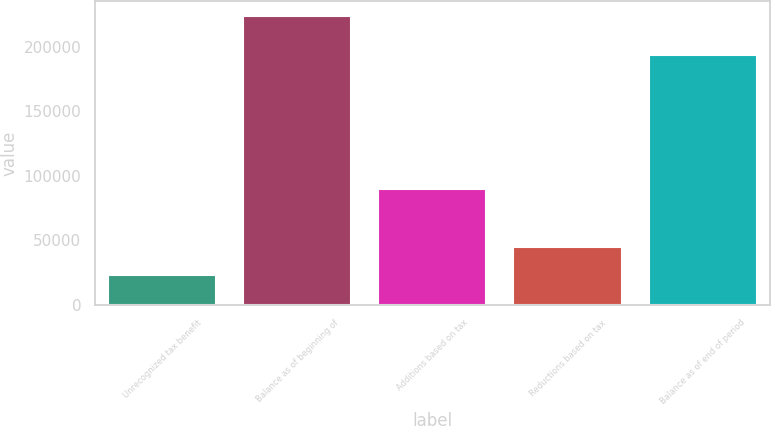Convert chart. <chart><loc_0><loc_0><loc_500><loc_500><bar_chart><fcel>Unrecognized tax benefit<fcel>Balance as of beginning of<fcel>Additions based on tax<fcel>Reductions based on tax<fcel>Balance as of end of period<nl><fcel>22846.6<fcel>224029<fcel>89907.4<fcel>45200.2<fcel>193320<nl></chart> 